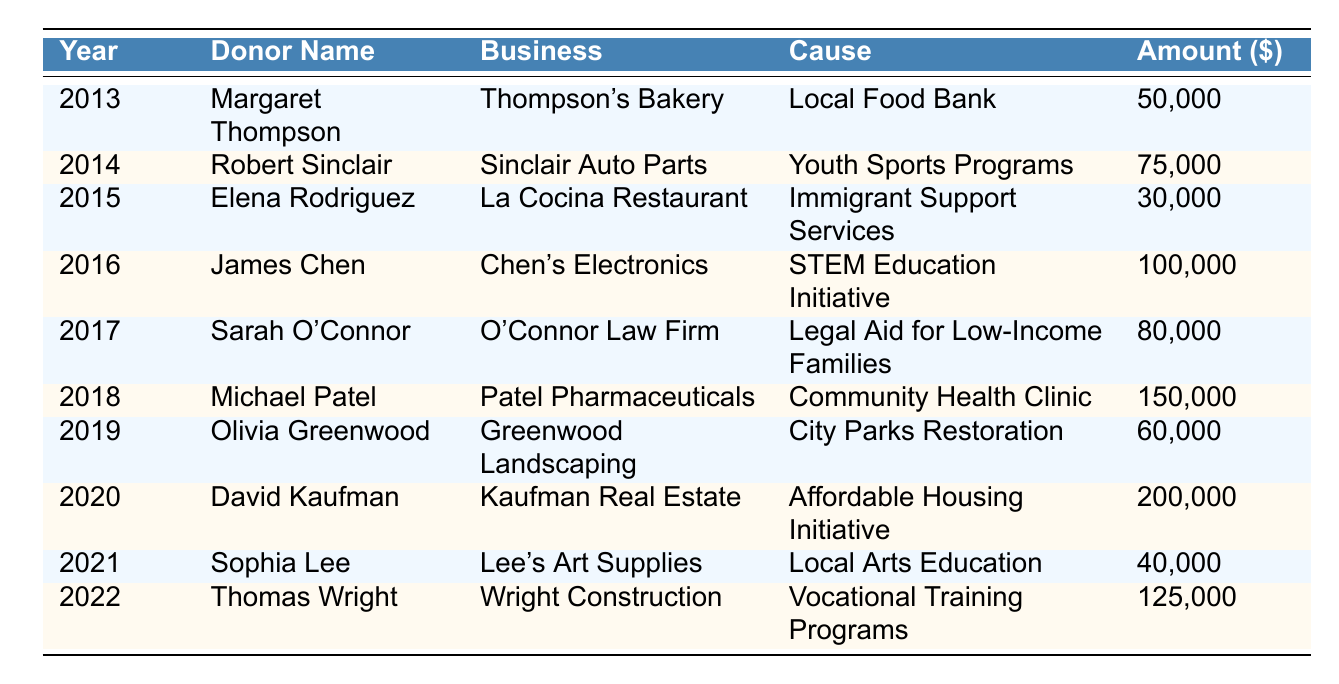What was the highest philanthropic contribution made by a business owner? Scanning through the table, the highest philanthropic contribution is $200,000 made by David Kaufman in 2020 for the Affordable Housing Initiative.
Answer: $200,000 Which business owner donated to the Local Food Bank? The table shows that Margaret Thompson from Thompson's Bakery made a donation to the Local Food Bank in 2013 for $50,000.
Answer: Margaret Thompson What is the total amount donated by all businesses from 2013 to 2022? Adding all the contributions listed in the table: 50000 + 75000 + 30000 + 100000 + 80000 + 150000 + 60000 + 200000 + 40000 + 125000 = 745000.
Answer: $745,000 In what year did Michael Patel make his donation, and how much was it? According to the table, Michael Patel donated $150,000 to the Community Health Clinic in 2018.
Answer: 2018; $150,000 How many years saw donations above $100,000? The table shows that there were three donations above $100,000: James Chen in 2016, Michael Patel in 2018, and David Kaufman in 2020. Thus, the answer is three.
Answer: 3 Which cause received the smallest donation and what was that amount? The smallest donation in the table is for Immigrant Support Services, which received $30,000 from Elena Rodriguez in 2015.
Answer: Immigrant Support Services; $30,000 Did any donor contribute to multiple causes, and if so, who? Reviewing the table, each donor contributed to a unique cause, indicating no repeat donors across different causes. Therefore, the answer is no.
Answer: No What was the average donation amount across all years? First, calculate the total donations ($745,000) made over 10 years, then divide by 10. The average donation is $745,000 / 10 = $74,500.
Answer: $74,500 Which year had a donor associated with the arts, and what was the contribution? From the table, in 2021 Sophia Lee from Lee's Art Supplies contributed $40,000 to Local Arts Education.
Answer: 2021; $40,000 Have there been donations specifically for youth-related causes? If so, how many? Yes, the table lists one donation specifically for youth-related causes in 2014 from Robert Sinclair for Youth Sports Programs.
Answer: 1 